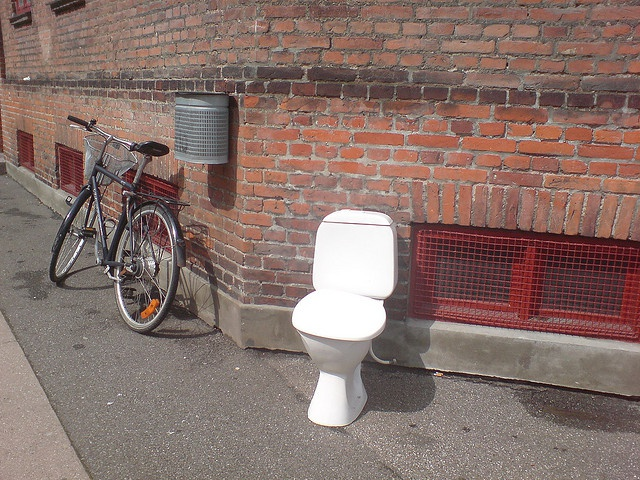Describe the objects in this image and their specific colors. I can see bicycle in gray, black, and darkgray tones and toilet in gray, white, and darkgray tones in this image. 